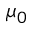Convert formula to latex. <formula><loc_0><loc_0><loc_500><loc_500>\mu _ { 0 }</formula> 